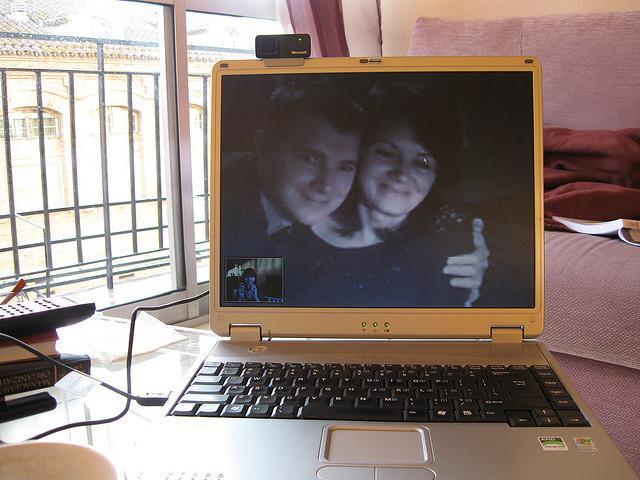How many people are shown on the computer?
Give a very brief answer. 2. How many people are visible?
Give a very brief answer. 2. How many couches can you see?
Give a very brief answer. 2. 